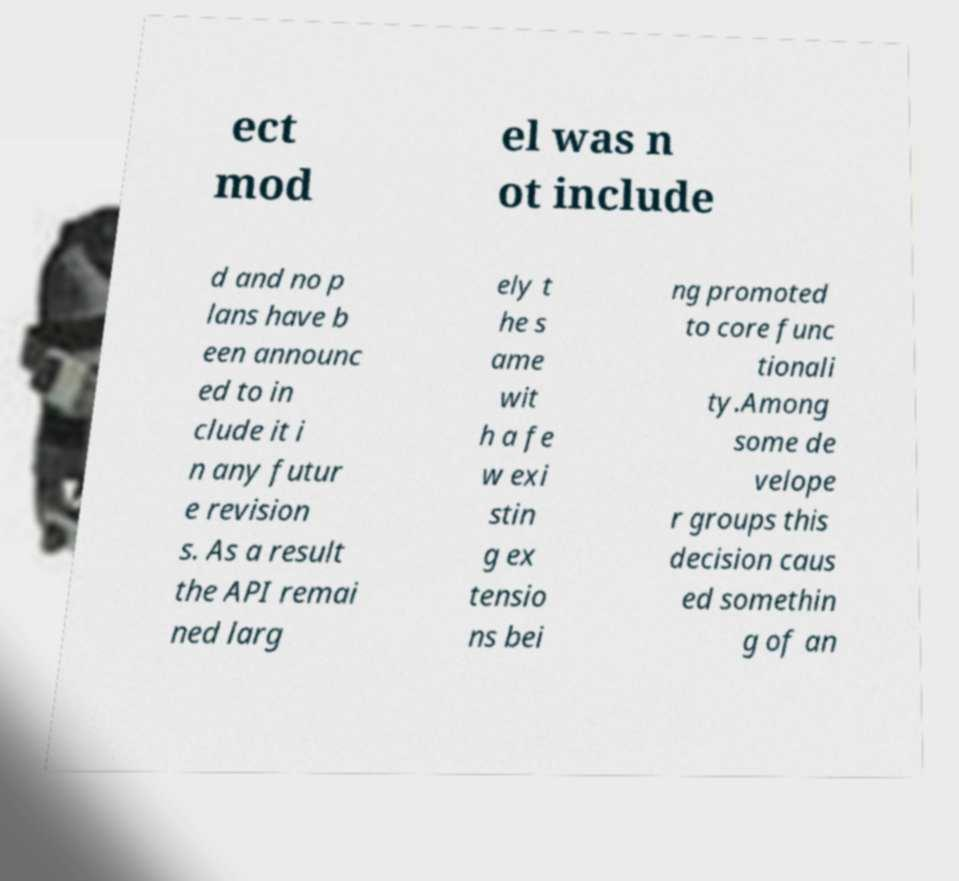Could you extract and type out the text from this image? ect mod el was n ot include d and no p lans have b een announc ed to in clude it i n any futur e revision s. As a result the API remai ned larg ely t he s ame wit h a fe w exi stin g ex tensio ns bei ng promoted to core func tionali ty.Among some de velope r groups this decision caus ed somethin g of an 